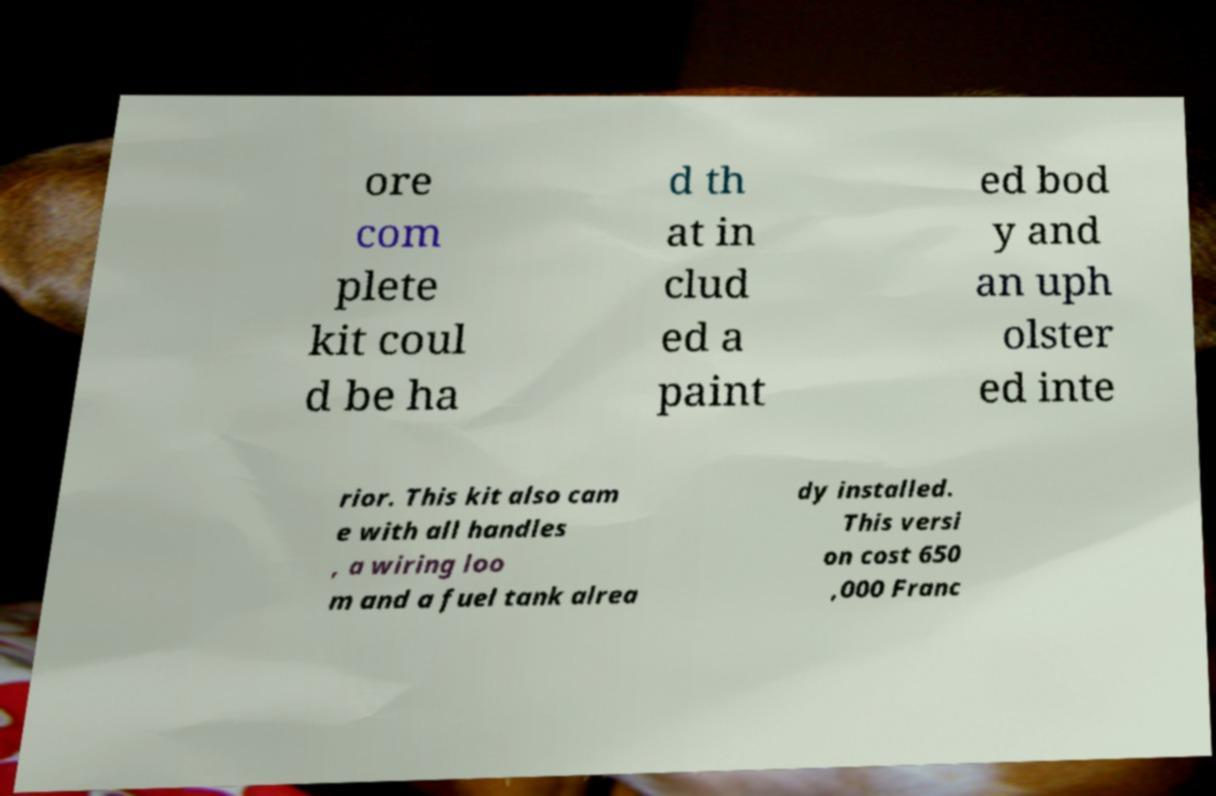There's text embedded in this image that I need extracted. Can you transcribe it verbatim? ore com plete kit coul d be ha d th at in clud ed a paint ed bod y and an uph olster ed inte rior. This kit also cam e with all handles , a wiring loo m and a fuel tank alrea dy installed. This versi on cost 650 ,000 Franc 